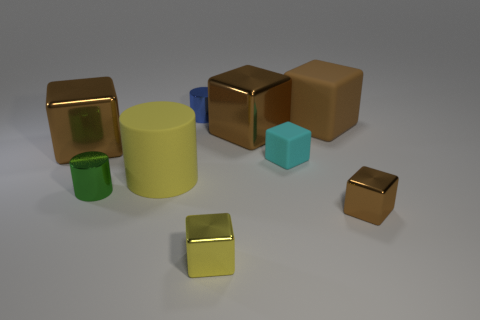Describe the lighting in the scene. Where do you think the light source is located? The scene appears to be uniformly lit with a diffuse overhead light source, which creates soft shadows directly underneath the shapes with minimal directional bias. 